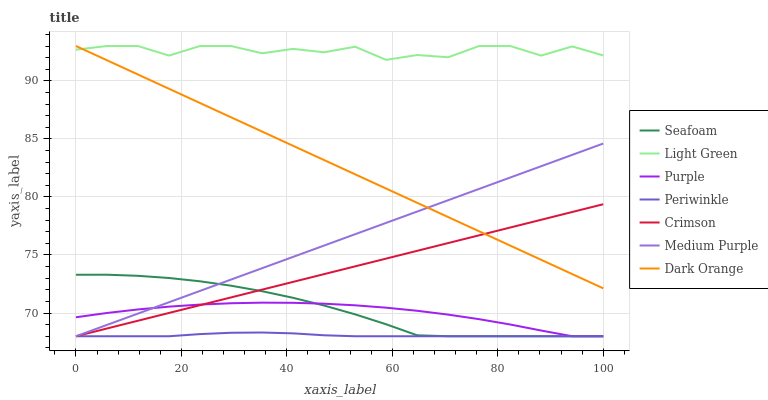Does Purple have the minimum area under the curve?
Answer yes or no. No. Does Purple have the maximum area under the curve?
Answer yes or no. No. Is Purple the smoothest?
Answer yes or no. No. Is Purple the roughest?
Answer yes or no. No. Does Light Green have the lowest value?
Answer yes or no. No. Does Purple have the highest value?
Answer yes or no. No. Is Crimson less than Light Green?
Answer yes or no. Yes. Is Light Green greater than Medium Purple?
Answer yes or no. Yes. Does Crimson intersect Light Green?
Answer yes or no. No. 